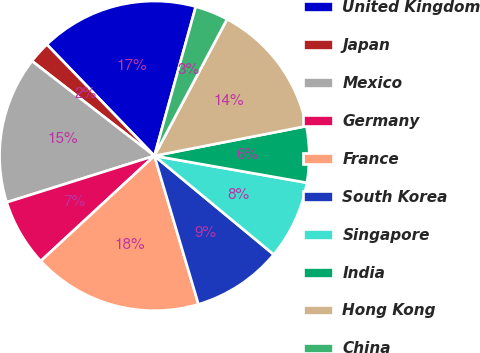<chart> <loc_0><loc_0><loc_500><loc_500><pie_chart><fcel>United Kingdom<fcel>Japan<fcel>Mexico<fcel>Germany<fcel>France<fcel>South Korea<fcel>Singapore<fcel>India<fcel>Hong Kong<fcel>China<nl><fcel>16.53%<fcel>2.29%<fcel>15.34%<fcel>7.03%<fcel>17.71%<fcel>9.41%<fcel>8.22%<fcel>5.85%<fcel>14.15%<fcel>3.47%<nl></chart> 